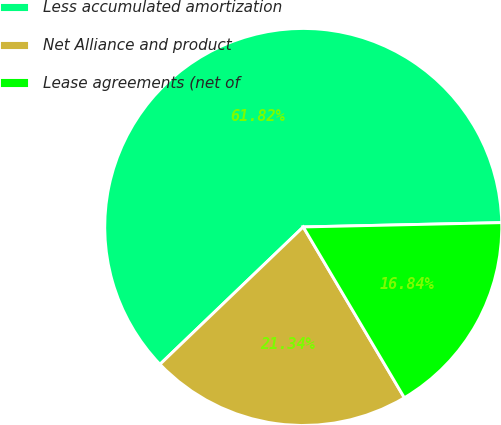Convert chart to OTSL. <chart><loc_0><loc_0><loc_500><loc_500><pie_chart><fcel>Less accumulated amortization<fcel>Net Alliance and product<fcel>Lease agreements (net of<nl><fcel>61.82%<fcel>21.34%<fcel>16.84%<nl></chart> 